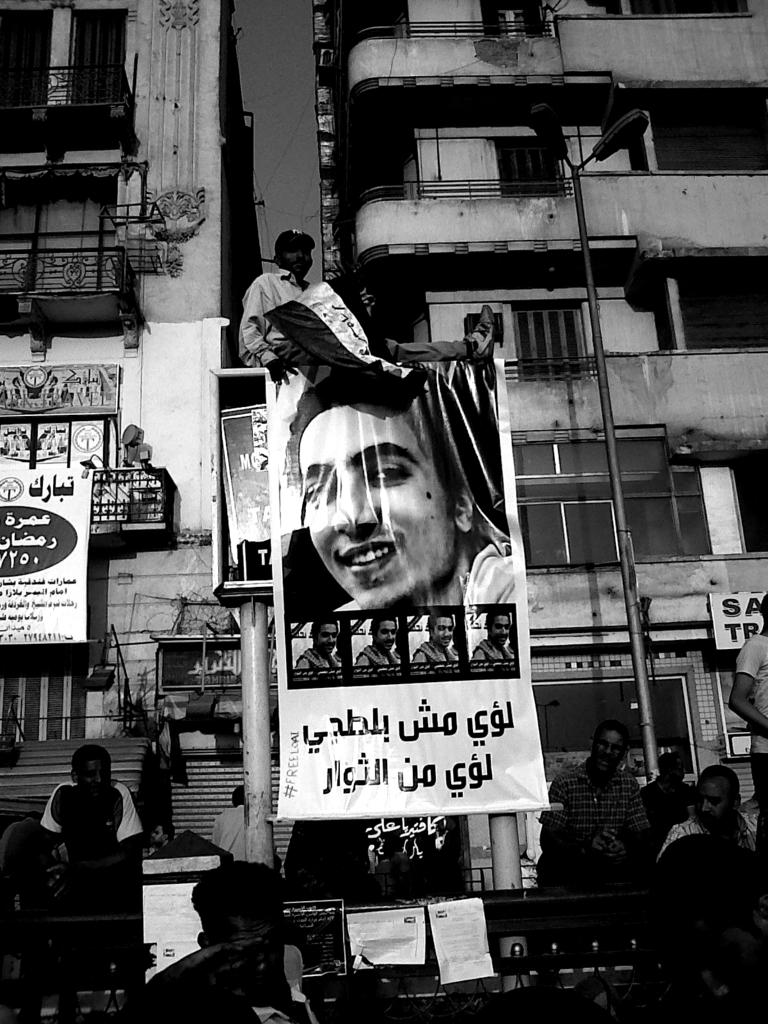What is the man in the image doing? The man is sitting on a board in the center of the image. What can be seen hanging or displayed in the image? There is a banner in the image. Who or what is visible at the bottom of the image? People are visible at the bottom of the image. What type of barrier is present at the bottom of the image? There is a fence at the bottom of the image. What can be seen providing illumination at the bottom of the image? Lights are present at the bottom of the image. What type of structures can be seen in the distance in the image? There are buildings in the background of the image. Can you tell me how many cats are sitting on the man's lap in the image? There are no cats present in the image; the man is sitting on a board. 